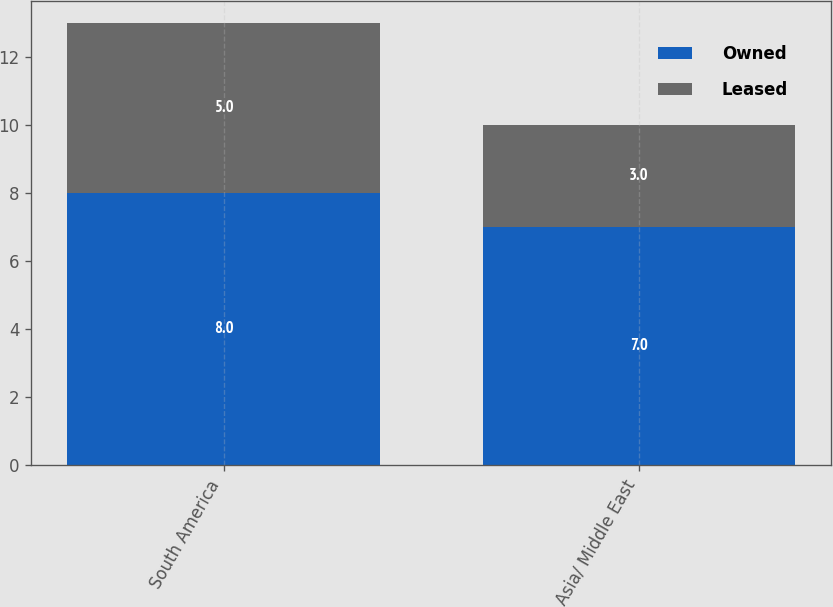Convert chart. <chart><loc_0><loc_0><loc_500><loc_500><stacked_bar_chart><ecel><fcel>South America<fcel>Asia/ Middle East<nl><fcel>Owned<fcel>8<fcel>7<nl><fcel>Leased<fcel>5<fcel>3<nl></chart> 